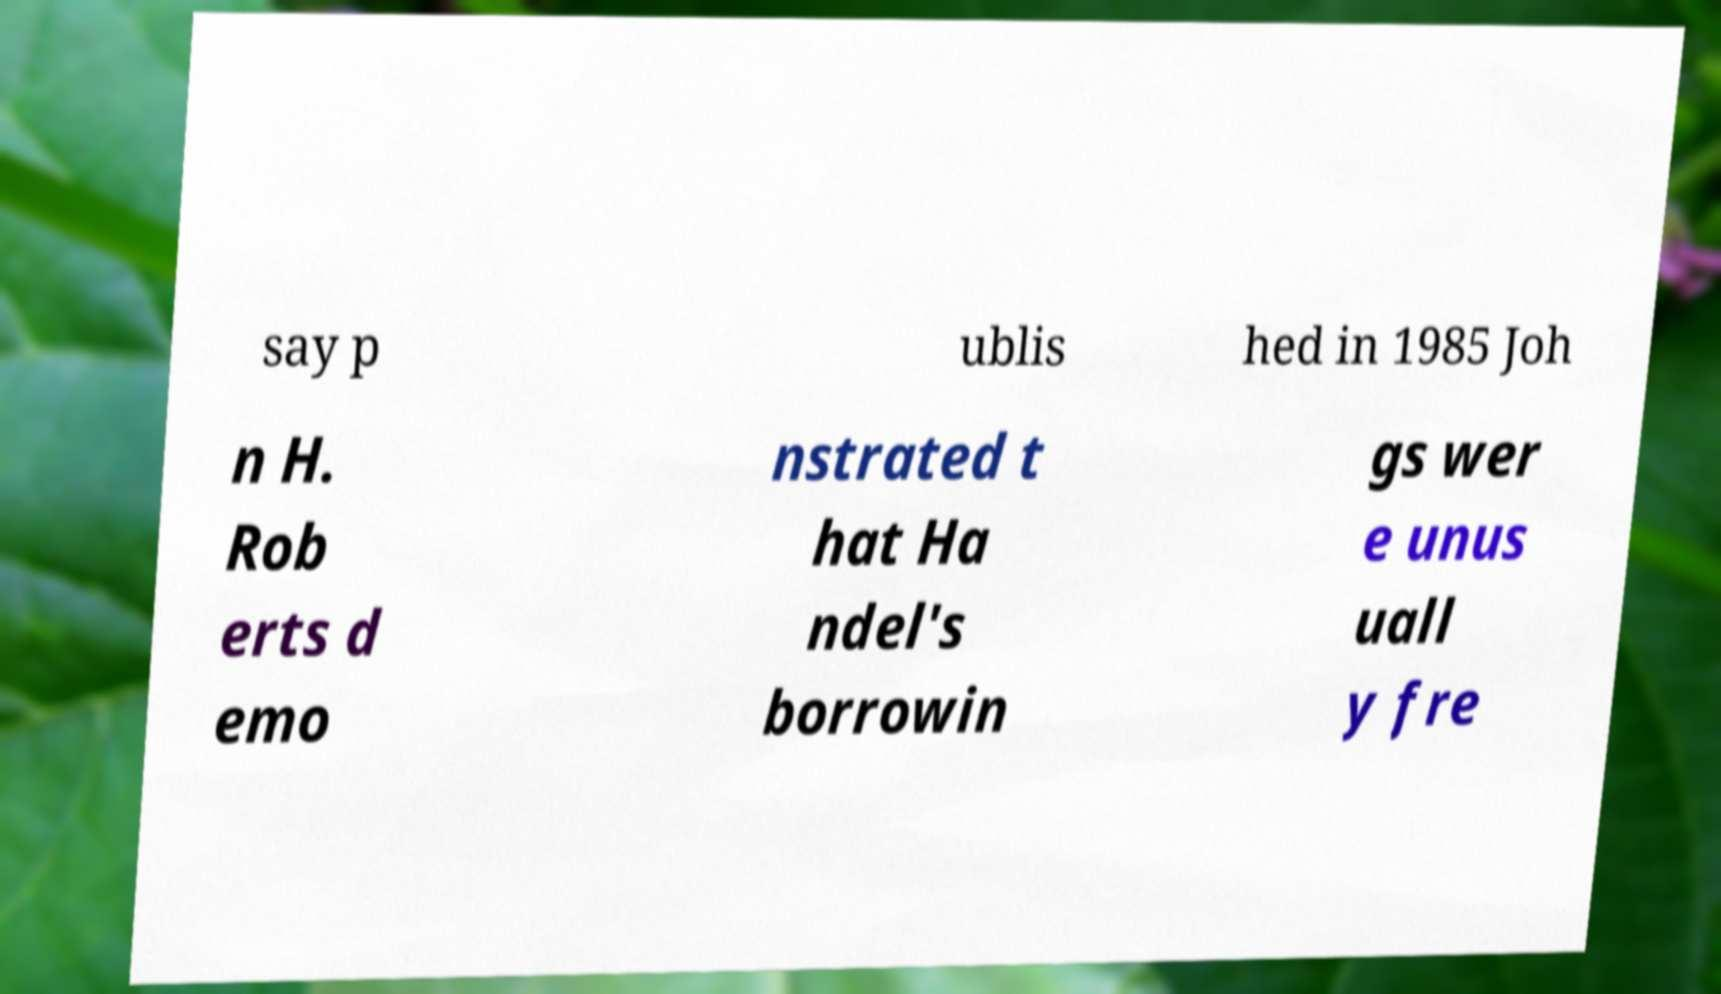For documentation purposes, I need the text within this image transcribed. Could you provide that? say p ublis hed in 1985 Joh n H. Rob erts d emo nstrated t hat Ha ndel's borrowin gs wer e unus uall y fre 